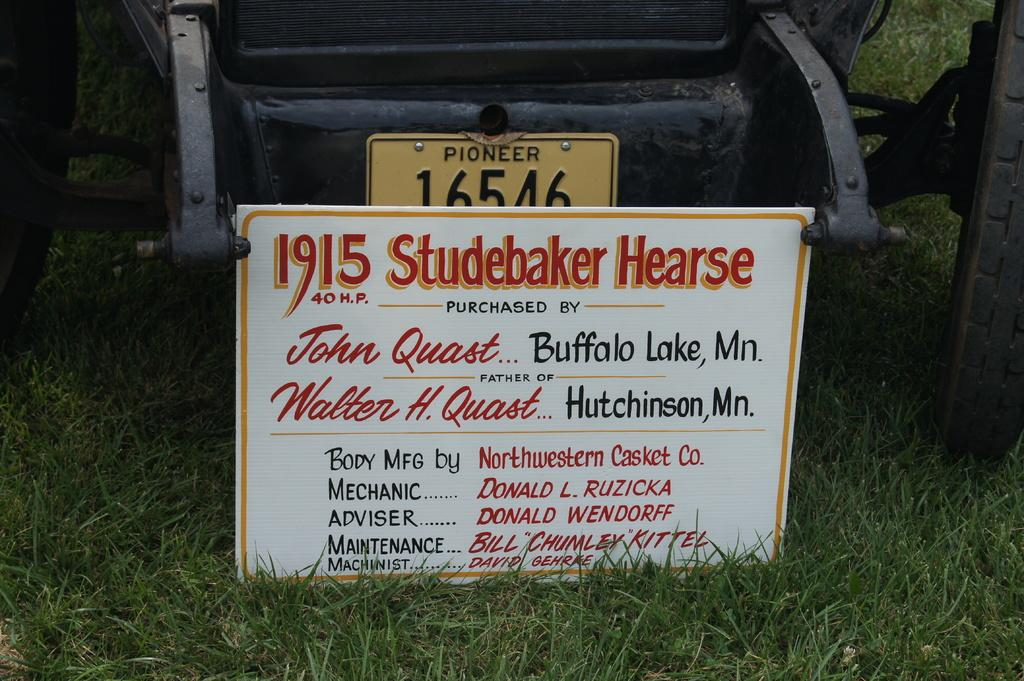What is the main subject in the center of the image? There is a vehicle in the center of the image. What can be seen on the vehicle? The vehicle has a number plate. What else is present on the ground in the image? There is a board on the ground in the image. What type of grass is growing on the peace symbol in the image? There is no grass or peace symbol present in the image. 